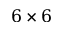<formula> <loc_0><loc_0><loc_500><loc_500>6 \times 6</formula> 